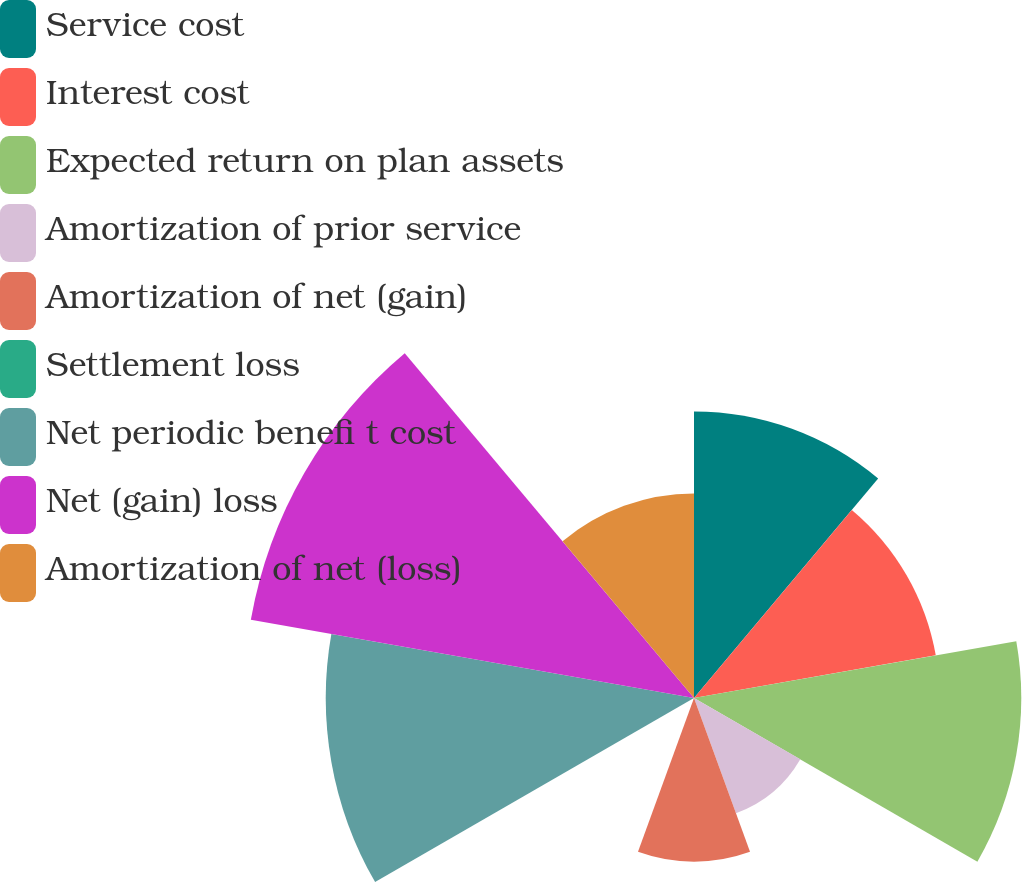<chart> <loc_0><loc_0><loc_500><loc_500><pie_chart><fcel>Service cost<fcel>Interest cost<fcel>Expected return on plan assets<fcel>Amortization of prior service<fcel>Amortization of net (gain)<fcel>Settlement loss<fcel>Net periodic benefi t cost<fcel>Net (gain) loss<fcel>Amortization of net (loss)<nl><fcel>13.21%<fcel>11.32%<fcel>15.09%<fcel>5.66%<fcel>7.55%<fcel>0.0%<fcel>16.98%<fcel>20.75%<fcel>9.43%<nl></chart> 